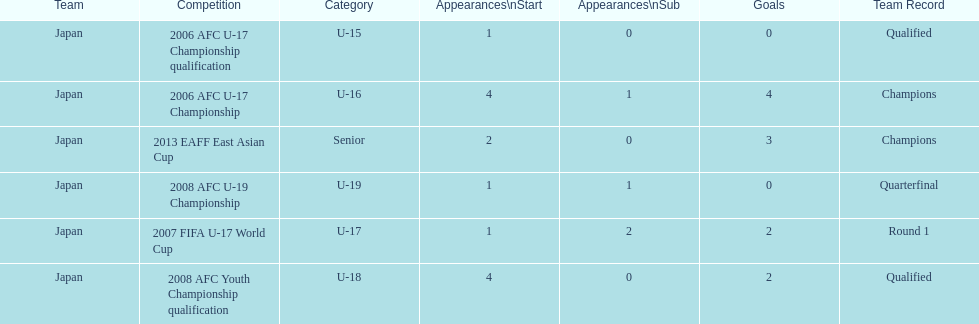In which major competitions did yoichiro kakitani have at least 3 starts? 2006 AFC U-17 Championship, 2008 AFC Youth Championship qualification. 